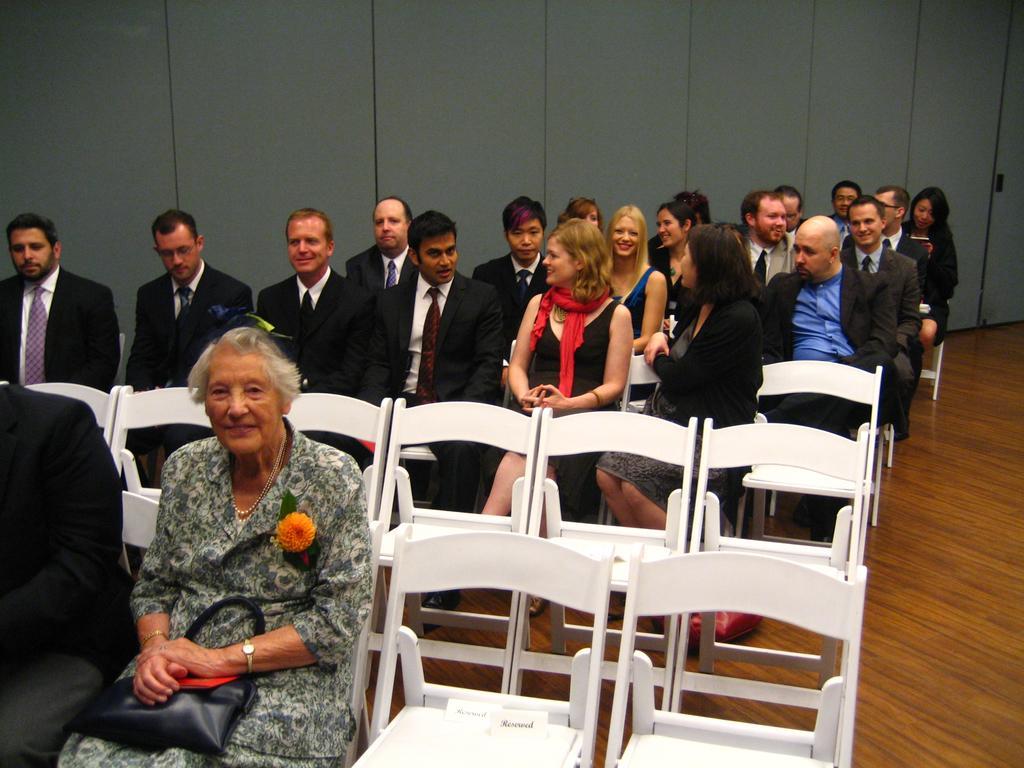Could you give a brief overview of what you see in this image? Group of people are sitting on a chair. This woman is carrying a bag. This woman wore scarf. Most of the persons wore black suit and tie. Those chairs are in white color. 